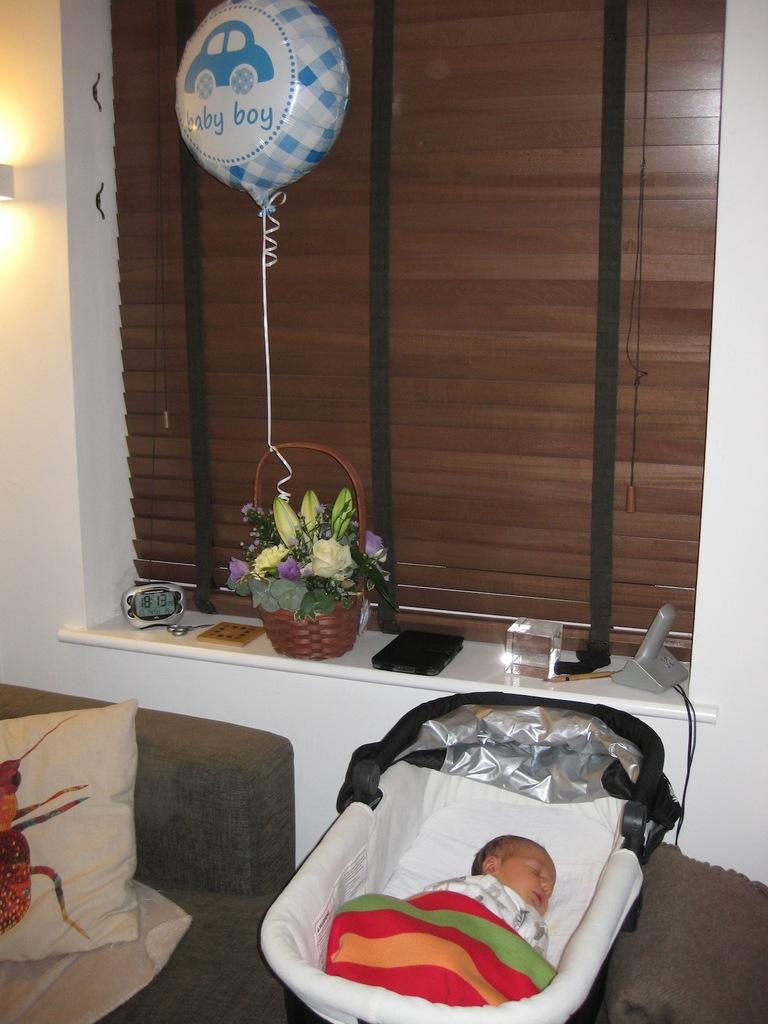What is the main subject of the image? There is a baby in the image. Where is the baby located? The baby is in a bed. What other furniture is visible in the image? There is a couch in the image. What can be seen on the window? There are objects on the window. What type of wood is used to make the music that can be heard in the image? There is no music present in the image, and therefore no wood can be associated with it. 